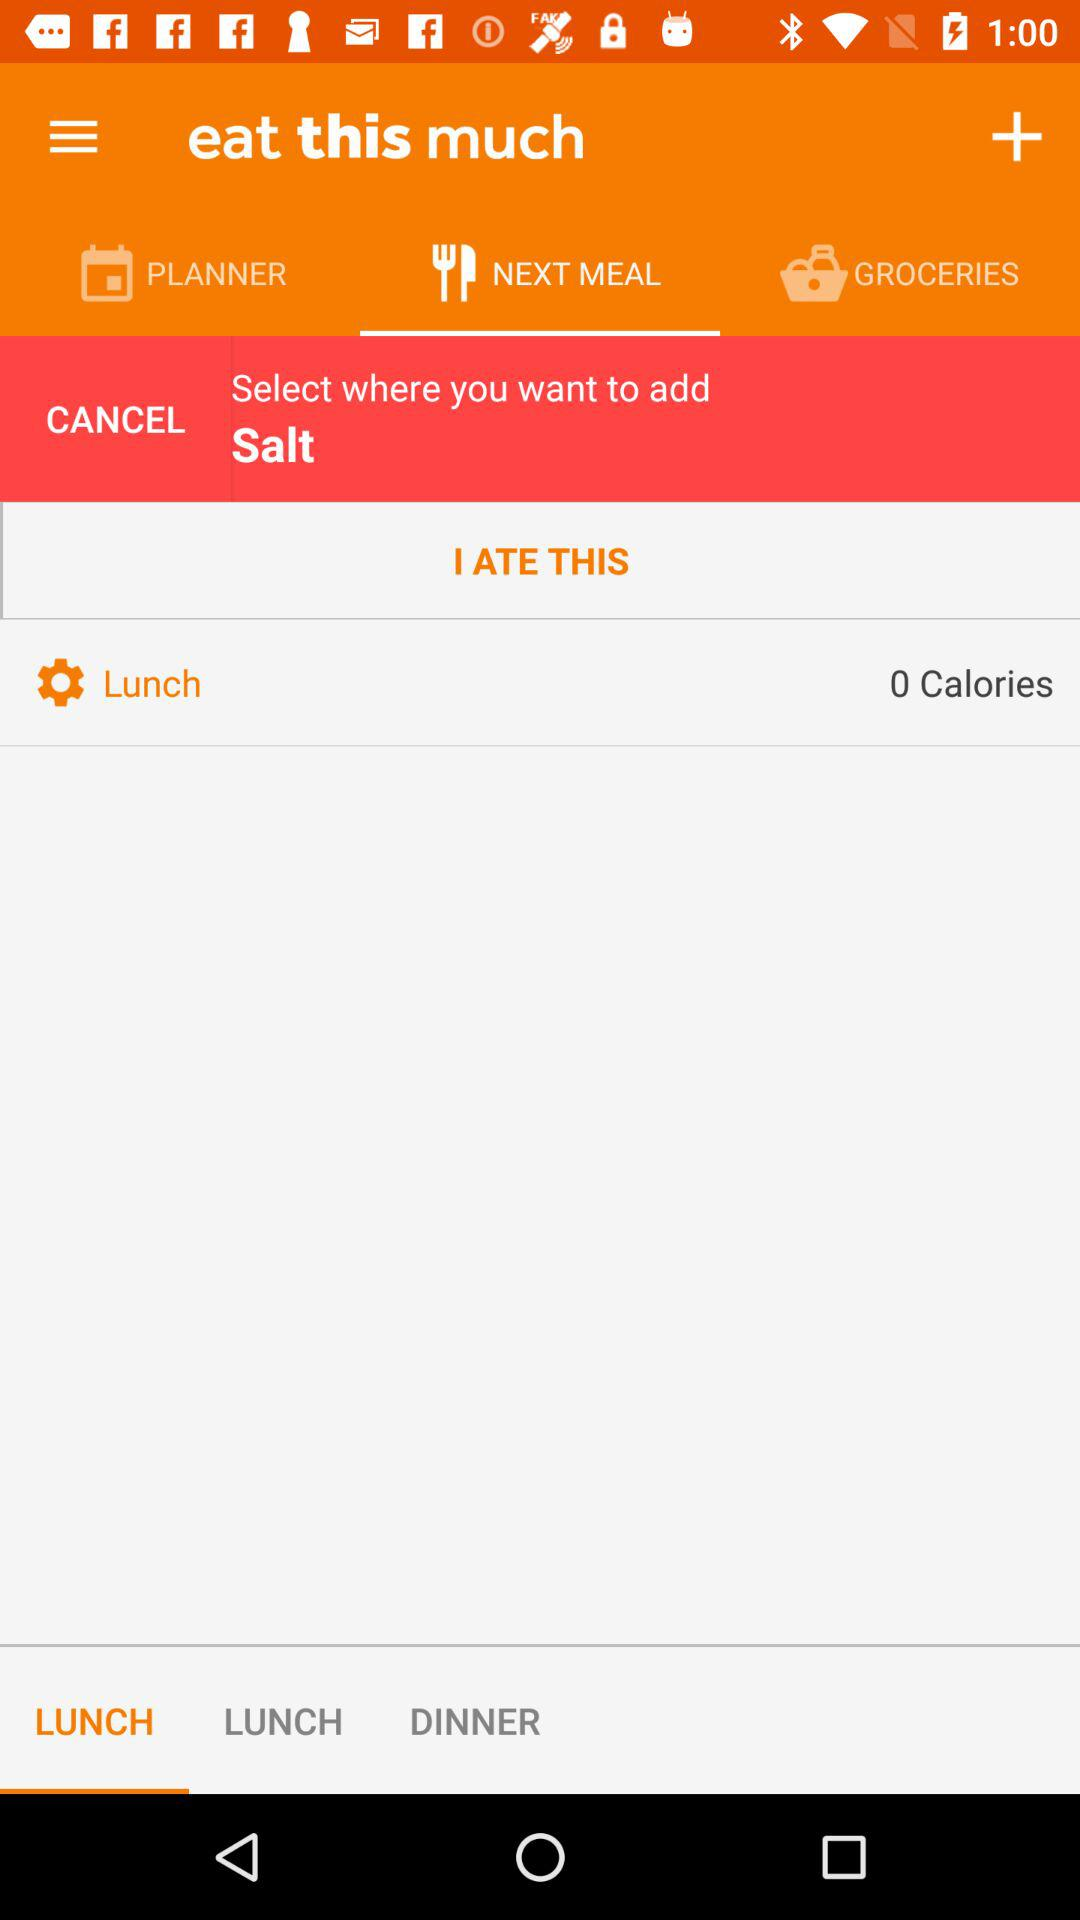How many calories does the user have left for lunch?
Answer the question using a single word or phrase. 0 